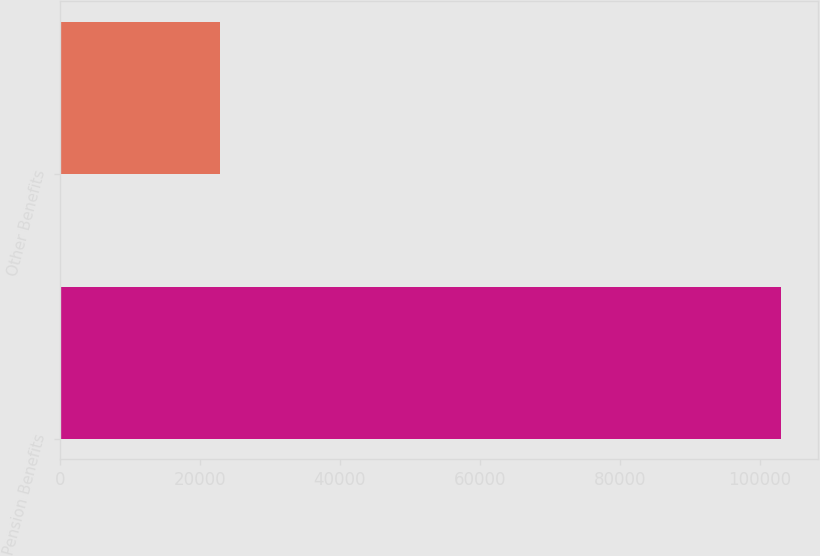Convert chart to OTSL. <chart><loc_0><loc_0><loc_500><loc_500><bar_chart><fcel>Pension Benefits<fcel>Other Benefits<nl><fcel>103081<fcel>22933<nl></chart> 